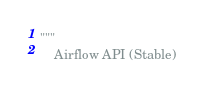Convert code to text. <code><loc_0><loc_0><loc_500><loc_500><_Python_>"""
    Airflow API (Stable)
</code> 